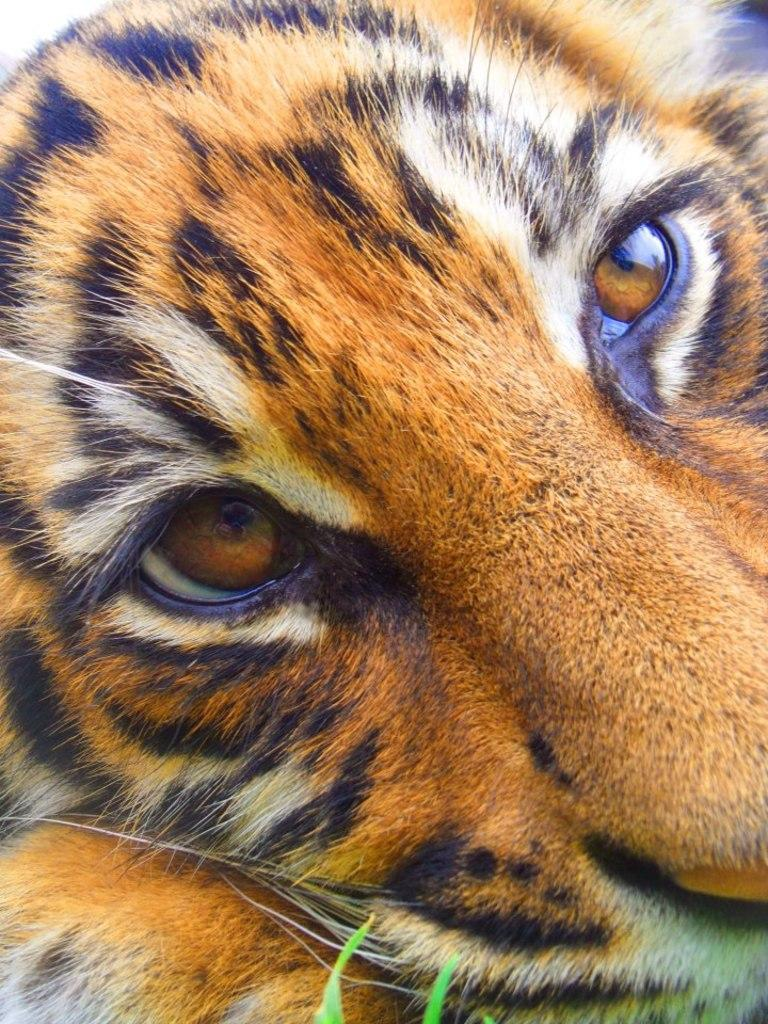What animal's face is depicted in the image? There is a tiger's face in the image. What can be seen at the bottom of the image? There are leaves at the bottom of the image. Can you see a tree swinging in the image? There is no tree or swing present in the image. Is the tiger flying in the image? The tiger is not flying in the image; it is depicted as a face. 